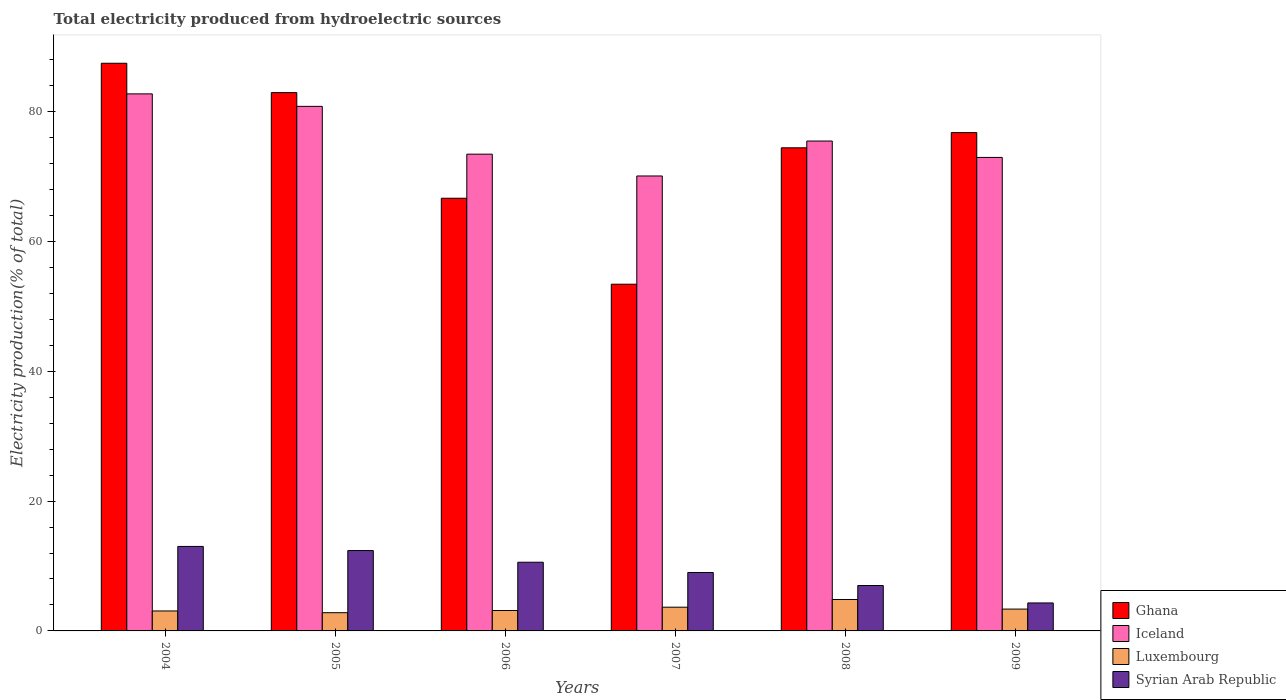Are the number of bars per tick equal to the number of legend labels?
Your response must be concise. Yes. How many bars are there on the 6th tick from the right?
Keep it short and to the point. 4. What is the label of the 4th group of bars from the left?
Provide a succinct answer. 2007. What is the total electricity produced in Luxembourg in 2006?
Your response must be concise. 3.15. Across all years, what is the maximum total electricity produced in Luxembourg?
Provide a succinct answer. 4.84. Across all years, what is the minimum total electricity produced in Iceland?
Provide a short and direct response. 70.08. What is the total total electricity produced in Iceland in the graph?
Your answer should be compact. 455.48. What is the difference between the total electricity produced in Iceland in 2004 and that in 2006?
Provide a short and direct response. 9.29. What is the difference between the total electricity produced in Luxembourg in 2008 and the total electricity produced in Iceland in 2006?
Ensure brevity in your answer.  -68.6. What is the average total electricity produced in Syrian Arab Republic per year?
Your answer should be compact. 9.38. In the year 2008, what is the difference between the total electricity produced in Syrian Arab Republic and total electricity produced in Iceland?
Ensure brevity in your answer.  -68.47. In how many years, is the total electricity produced in Iceland greater than 56 %?
Offer a terse response. 6. What is the ratio of the total electricity produced in Luxembourg in 2004 to that in 2005?
Your answer should be compact. 1.1. Is the total electricity produced in Luxembourg in 2006 less than that in 2009?
Offer a very short reply. Yes. Is the difference between the total electricity produced in Syrian Arab Republic in 2005 and 2006 greater than the difference between the total electricity produced in Iceland in 2005 and 2006?
Offer a very short reply. No. What is the difference between the highest and the second highest total electricity produced in Ghana?
Provide a short and direct response. 4.52. What is the difference between the highest and the lowest total electricity produced in Iceland?
Your response must be concise. 12.65. Is the sum of the total electricity produced in Syrian Arab Republic in 2005 and 2008 greater than the maximum total electricity produced in Luxembourg across all years?
Give a very brief answer. Yes. Is it the case that in every year, the sum of the total electricity produced in Iceland and total electricity produced in Ghana is greater than the sum of total electricity produced in Luxembourg and total electricity produced in Syrian Arab Republic?
Your answer should be very brief. No. What does the 4th bar from the left in 2009 represents?
Offer a terse response. Syrian Arab Republic. What does the 3rd bar from the right in 2005 represents?
Make the answer very short. Iceland. How many bars are there?
Provide a succinct answer. 24. Are all the bars in the graph horizontal?
Offer a terse response. No. Are the values on the major ticks of Y-axis written in scientific E-notation?
Your answer should be very brief. No. Does the graph contain grids?
Provide a succinct answer. No. How many legend labels are there?
Your response must be concise. 4. What is the title of the graph?
Offer a very short reply. Total electricity produced from hydroelectric sources. What is the Electricity production(% of total) of Ghana in 2004?
Make the answer very short. 87.45. What is the Electricity production(% of total) of Iceland in 2004?
Offer a very short reply. 82.73. What is the Electricity production(% of total) of Luxembourg in 2004?
Ensure brevity in your answer.  3.08. What is the Electricity production(% of total) in Syrian Arab Republic in 2004?
Keep it short and to the point. 13.02. What is the Electricity production(% of total) in Ghana in 2005?
Make the answer very short. 82.93. What is the Electricity production(% of total) of Iceland in 2005?
Keep it short and to the point. 80.81. What is the Electricity production(% of total) of Luxembourg in 2005?
Provide a succinct answer. 2.81. What is the Electricity production(% of total) in Syrian Arab Republic in 2005?
Your answer should be very brief. 12.38. What is the Electricity production(% of total) of Ghana in 2006?
Keep it short and to the point. 66.65. What is the Electricity production(% of total) in Iceland in 2006?
Your answer should be compact. 73.44. What is the Electricity production(% of total) in Luxembourg in 2006?
Your answer should be compact. 3.15. What is the Electricity production(% of total) of Syrian Arab Republic in 2006?
Make the answer very short. 10.58. What is the Electricity production(% of total) in Ghana in 2007?
Provide a short and direct response. 53.41. What is the Electricity production(% of total) in Iceland in 2007?
Your response must be concise. 70.08. What is the Electricity production(% of total) of Luxembourg in 2007?
Your answer should be very brief. 3.66. What is the Electricity production(% of total) in Syrian Arab Republic in 2007?
Provide a succinct answer. 9. What is the Electricity production(% of total) of Ghana in 2008?
Your answer should be compact. 74.42. What is the Electricity production(% of total) in Iceland in 2008?
Give a very brief answer. 75.47. What is the Electricity production(% of total) of Luxembourg in 2008?
Offer a terse response. 4.84. What is the Electricity production(% of total) of Syrian Arab Republic in 2008?
Provide a succinct answer. 6.99. What is the Electricity production(% of total) in Ghana in 2009?
Your answer should be very brief. 76.77. What is the Electricity production(% of total) in Iceland in 2009?
Ensure brevity in your answer.  72.94. What is the Electricity production(% of total) of Luxembourg in 2009?
Your answer should be compact. 3.36. What is the Electricity production(% of total) in Syrian Arab Republic in 2009?
Your answer should be very brief. 4.31. Across all years, what is the maximum Electricity production(% of total) of Ghana?
Provide a succinct answer. 87.45. Across all years, what is the maximum Electricity production(% of total) of Iceland?
Your response must be concise. 82.73. Across all years, what is the maximum Electricity production(% of total) of Luxembourg?
Offer a terse response. 4.84. Across all years, what is the maximum Electricity production(% of total) of Syrian Arab Republic?
Ensure brevity in your answer.  13.02. Across all years, what is the minimum Electricity production(% of total) in Ghana?
Provide a short and direct response. 53.41. Across all years, what is the minimum Electricity production(% of total) in Iceland?
Make the answer very short. 70.08. Across all years, what is the minimum Electricity production(% of total) in Luxembourg?
Provide a short and direct response. 2.81. Across all years, what is the minimum Electricity production(% of total) of Syrian Arab Republic?
Ensure brevity in your answer.  4.31. What is the total Electricity production(% of total) in Ghana in the graph?
Give a very brief answer. 441.63. What is the total Electricity production(% of total) of Iceland in the graph?
Keep it short and to the point. 455.48. What is the total Electricity production(% of total) in Luxembourg in the graph?
Keep it short and to the point. 20.89. What is the total Electricity production(% of total) in Syrian Arab Republic in the graph?
Ensure brevity in your answer.  56.28. What is the difference between the Electricity production(% of total) in Ghana in 2004 and that in 2005?
Your response must be concise. 4.52. What is the difference between the Electricity production(% of total) in Iceland in 2004 and that in 2005?
Keep it short and to the point. 1.92. What is the difference between the Electricity production(% of total) of Luxembourg in 2004 and that in 2005?
Your answer should be very brief. 0.27. What is the difference between the Electricity production(% of total) of Syrian Arab Republic in 2004 and that in 2005?
Your response must be concise. 0.64. What is the difference between the Electricity production(% of total) of Ghana in 2004 and that in 2006?
Provide a short and direct response. 20.79. What is the difference between the Electricity production(% of total) of Iceland in 2004 and that in 2006?
Your answer should be compact. 9.29. What is the difference between the Electricity production(% of total) in Luxembourg in 2004 and that in 2006?
Your answer should be compact. -0.07. What is the difference between the Electricity production(% of total) of Syrian Arab Republic in 2004 and that in 2006?
Your response must be concise. 2.43. What is the difference between the Electricity production(% of total) in Ghana in 2004 and that in 2007?
Your answer should be very brief. 34.04. What is the difference between the Electricity production(% of total) in Iceland in 2004 and that in 2007?
Offer a terse response. 12.65. What is the difference between the Electricity production(% of total) of Luxembourg in 2004 and that in 2007?
Ensure brevity in your answer.  -0.58. What is the difference between the Electricity production(% of total) of Syrian Arab Republic in 2004 and that in 2007?
Your response must be concise. 4.01. What is the difference between the Electricity production(% of total) of Ghana in 2004 and that in 2008?
Your answer should be very brief. 13.02. What is the difference between the Electricity production(% of total) of Iceland in 2004 and that in 2008?
Your answer should be very brief. 7.27. What is the difference between the Electricity production(% of total) in Luxembourg in 2004 and that in 2008?
Offer a very short reply. -1.77. What is the difference between the Electricity production(% of total) in Syrian Arab Republic in 2004 and that in 2008?
Your answer should be compact. 6.02. What is the difference between the Electricity production(% of total) of Ghana in 2004 and that in 2009?
Provide a short and direct response. 10.68. What is the difference between the Electricity production(% of total) in Iceland in 2004 and that in 2009?
Make the answer very short. 9.79. What is the difference between the Electricity production(% of total) in Luxembourg in 2004 and that in 2009?
Ensure brevity in your answer.  -0.29. What is the difference between the Electricity production(% of total) in Syrian Arab Republic in 2004 and that in 2009?
Your answer should be very brief. 8.71. What is the difference between the Electricity production(% of total) in Ghana in 2005 and that in 2006?
Your answer should be very brief. 16.27. What is the difference between the Electricity production(% of total) of Iceland in 2005 and that in 2006?
Offer a terse response. 7.36. What is the difference between the Electricity production(% of total) of Luxembourg in 2005 and that in 2006?
Keep it short and to the point. -0.34. What is the difference between the Electricity production(% of total) of Syrian Arab Republic in 2005 and that in 2006?
Ensure brevity in your answer.  1.8. What is the difference between the Electricity production(% of total) in Ghana in 2005 and that in 2007?
Make the answer very short. 29.52. What is the difference between the Electricity production(% of total) in Iceland in 2005 and that in 2007?
Make the answer very short. 10.72. What is the difference between the Electricity production(% of total) in Luxembourg in 2005 and that in 2007?
Provide a succinct answer. -0.85. What is the difference between the Electricity production(% of total) in Syrian Arab Republic in 2005 and that in 2007?
Make the answer very short. 3.38. What is the difference between the Electricity production(% of total) of Ghana in 2005 and that in 2008?
Provide a succinct answer. 8.5. What is the difference between the Electricity production(% of total) in Iceland in 2005 and that in 2008?
Provide a succinct answer. 5.34. What is the difference between the Electricity production(% of total) of Luxembourg in 2005 and that in 2008?
Your response must be concise. -2.03. What is the difference between the Electricity production(% of total) of Syrian Arab Republic in 2005 and that in 2008?
Provide a short and direct response. 5.39. What is the difference between the Electricity production(% of total) of Ghana in 2005 and that in 2009?
Make the answer very short. 6.16. What is the difference between the Electricity production(% of total) in Iceland in 2005 and that in 2009?
Give a very brief answer. 7.87. What is the difference between the Electricity production(% of total) in Luxembourg in 2005 and that in 2009?
Offer a very short reply. -0.56. What is the difference between the Electricity production(% of total) in Syrian Arab Republic in 2005 and that in 2009?
Your answer should be very brief. 8.07. What is the difference between the Electricity production(% of total) in Ghana in 2006 and that in 2007?
Give a very brief answer. 13.24. What is the difference between the Electricity production(% of total) of Iceland in 2006 and that in 2007?
Your response must be concise. 3.36. What is the difference between the Electricity production(% of total) in Luxembourg in 2006 and that in 2007?
Your answer should be very brief. -0.51. What is the difference between the Electricity production(% of total) of Syrian Arab Republic in 2006 and that in 2007?
Make the answer very short. 1.58. What is the difference between the Electricity production(% of total) in Ghana in 2006 and that in 2008?
Offer a very short reply. -7.77. What is the difference between the Electricity production(% of total) in Iceland in 2006 and that in 2008?
Ensure brevity in your answer.  -2.02. What is the difference between the Electricity production(% of total) of Luxembourg in 2006 and that in 2008?
Your answer should be compact. -1.7. What is the difference between the Electricity production(% of total) of Syrian Arab Republic in 2006 and that in 2008?
Provide a succinct answer. 3.59. What is the difference between the Electricity production(% of total) of Ghana in 2006 and that in 2009?
Provide a short and direct response. -10.11. What is the difference between the Electricity production(% of total) in Iceland in 2006 and that in 2009?
Make the answer very short. 0.5. What is the difference between the Electricity production(% of total) of Luxembourg in 2006 and that in 2009?
Provide a succinct answer. -0.22. What is the difference between the Electricity production(% of total) in Syrian Arab Republic in 2006 and that in 2009?
Your response must be concise. 6.27. What is the difference between the Electricity production(% of total) in Ghana in 2007 and that in 2008?
Give a very brief answer. -21.01. What is the difference between the Electricity production(% of total) of Iceland in 2007 and that in 2008?
Your response must be concise. -5.38. What is the difference between the Electricity production(% of total) in Luxembourg in 2007 and that in 2008?
Your response must be concise. -1.19. What is the difference between the Electricity production(% of total) of Syrian Arab Republic in 2007 and that in 2008?
Make the answer very short. 2.01. What is the difference between the Electricity production(% of total) of Ghana in 2007 and that in 2009?
Offer a very short reply. -23.36. What is the difference between the Electricity production(% of total) of Iceland in 2007 and that in 2009?
Provide a succinct answer. -2.86. What is the difference between the Electricity production(% of total) in Luxembourg in 2007 and that in 2009?
Keep it short and to the point. 0.29. What is the difference between the Electricity production(% of total) in Syrian Arab Republic in 2007 and that in 2009?
Your answer should be very brief. 4.69. What is the difference between the Electricity production(% of total) in Ghana in 2008 and that in 2009?
Offer a very short reply. -2.35. What is the difference between the Electricity production(% of total) of Iceland in 2008 and that in 2009?
Your response must be concise. 2.52. What is the difference between the Electricity production(% of total) of Luxembourg in 2008 and that in 2009?
Keep it short and to the point. 1.48. What is the difference between the Electricity production(% of total) in Syrian Arab Republic in 2008 and that in 2009?
Your answer should be compact. 2.69. What is the difference between the Electricity production(% of total) in Ghana in 2004 and the Electricity production(% of total) in Iceland in 2005?
Provide a short and direct response. 6.64. What is the difference between the Electricity production(% of total) in Ghana in 2004 and the Electricity production(% of total) in Luxembourg in 2005?
Keep it short and to the point. 84.64. What is the difference between the Electricity production(% of total) in Ghana in 2004 and the Electricity production(% of total) in Syrian Arab Republic in 2005?
Make the answer very short. 75.07. What is the difference between the Electricity production(% of total) of Iceland in 2004 and the Electricity production(% of total) of Luxembourg in 2005?
Make the answer very short. 79.92. What is the difference between the Electricity production(% of total) in Iceland in 2004 and the Electricity production(% of total) in Syrian Arab Republic in 2005?
Your answer should be very brief. 70.35. What is the difference between the Electricity production(% of total) of Luxembourg in 2004 and the Electricity production(% of total) of Syrian Arab Republic in 2005?
Ensure brevity in your answer.  -9.3. What is the difference between the Electricity production(% of total) in Ghana in 2004 and the Electricity production(% of total) in Iceland in 2006?
Your response must be concise. 14. What is the difference between the Electricity production(% of total) of Ghana in 2004 and the Electricity production(% of total) of Luxembourg in 2006?
Ensure brevity in your answer.  84.3. What is the difference between the Electricity production(% of total) of Ghana in 2004 and the Electricity production(% of total) of Syrian Arab Republic in 2006?
Your answer should be very brief. 76.87. What is the difference between the Electricity production(% of total) of Iceland in 2004 and the Electricity production(% of total) of Luxembourg in 2006?
Make the answer very short. 79.59. What is the difference between the Electricity production(% of total) in Iceland in 2004 and the Electricity production(% of total) in Syrian Arab Republic in 2006?
Ensure brevity in your answer.  72.15. What is the difference between the Electricity production(% of total) in Luxembourg in 2004 and the Electricity production(% of total) in Syrian Arab Republic in 2006?
Make the answer very short. -7.51. What is the difference between the Electricity production(% of total) in Ghana in 2004 and the Electricity production(% of total) in Iceland in 2007?
Your response must be concise. 17.36. What is the difference between the Electricity production(% of total) in Ghana in 2004 and the Electricity production(% of total) in Luxembourg in 2007?
Ensure brevity in your answer.  83.79. What is the difference between the Electricity production(% of total) in Ghana in 2004 and the Electricity production(% of total) in Syrian Arab Republic in 2007?
Give a very brief answer. 78.45. What is the difference between the Electricity production(% of total) of Iceland in 2004 and the Electricity production(% of total) of Luxembourg in 2007?
Ensure brevity in your answer.  79.08. What is the difference between the Electricity production(% of total) in Iceland in 2004 and the Electricity production(% of total) in Syrian Arab Republic in 2007?
Your answer should be compact. 73.73. What is the difference between the Electricity production(% of total) of Luxembourg in 2004 and the Electricity production(% of total) of Syrian Arab Republic in 2007?
Your response must be concise. -5.93. What is the difference between the Electricity production(% of total) of Ghana in 2004 and the Electricity production(% of total) of Iceland in 2008?
Ensure brevity in your answer.  11.98. What is the difference between the Electricity production(% of total) of Ghana in 2004 and the Electricity production(% of total) of Luxembourg in 2008?
Keep it short and to the point. 82.61. What is the difference between the Electricity production(% of total) of Ghana in 2004 and the Electricity production(% of total) of Syrian Arab Republic in 2008?
Give a very brief answer. 80.45. What is the difference between the Electricity production(% of total) in Iceland in 2004 and the Electricity production(% of total) in Luxembourg in 2008?
Offer a very short reply. 77.89. What is the difference between the Electricity production(% of total) of Iceland in 2004 and the Electricity production(% of total) of Syrian Arab Republic in 2008?
Offer a terse response. 75.74. What is the difference between the Electricity production(% of total) of Luxembourg in 2004 and the Electricity production(% of total) of Syrian Arab Republic in 2008?
Your answer should be very brief. -3.92. What is the difference between the Electricity production(% of total) of Ghana in 2004 and the Electricity production(% of total) of Iceland in 2009?
Your answer should be very brief. 14.51. What is the difference between the Electricity production(% of total) of Ghana in 2004 and the Electricity production(% of total) of Luxembourg in 2009?
Keep it short and to the point. 84.09. What is the difference between the Electricity production(% of total) in Ghana in 2004 and the Electricity production(% of total) in Syrian Arab Republic in 2009?
Provide a succinct answer. 83.14. What is the difference between the Electricity production(% of total) in Iceland in 2004 and the Electricity production(% of total) in Luxembourg in 2009?
Provide a short and direct response. 79.37. What is the difference between the Electricity production(% of total) in Iceland in 2004 and the Electricity production(% of total) in Syrian Arab Republic in 2009?
Offer a very short reply. 78.42. What is the difference between the Electricity production(% of total) in Luxembourg in 2004 and the Electricity production(% of total) in Syrian Arab Republic in 2009?
Your answer should be compact. -1.23. What is the difference between the Electricity production(% of total) of Ghana in 2005 and the Electricity production(% of total) of Iceland in 2006?
Provide a succinct answer. 9.48. What is the difference between the Electricity production(% of total) of Ghana in 2005 and the Electricity production(% of total) of Luxembourg in 2006?
Give a very brief answer. 79.78. What is the difference between the Electricity production(% of total) of Ghana in 2005 and the Electricity production(% of total) of Syrian Arab Republic in 2006?
Ensure brevity in your answer.  72.34. What is the difference between the Electricity production(% of total) in Iceland in 2005 and the Electricity production(% of total) in Luxembourg in 2006?
Keep it short and to the point. 77.66. What is the difference between the Electricity production(% of total) of Iceland in 2005 and the Electricity production(% of total) of Syrian Arab Republic in 2006?
Give a very brief answer. 70.23. What is the difference between the Electricity production(% of total) in Luxembourg in 2005 and the Electricity production(% of total) in Syrian Arab Republic in 2006?
Provide a succinct answer. -7.77. What is the difference between the Electricity production(% of total) in Ghana in 2005 and the Electricity production(% of total) in Iceland in 2007?
Make the answer very short. 12.84. What is the difference between the Electricity production(% of total) in Ghana in 2005 and the Electricity production(% of total) in Luxembourg in 2007?
Provide a succinct answer. 79.27. What is the difference between the Electricity production(% of total) in Ghana in 2005 and the Electricity production(% of total) in Syrian Arab Republic in 2007?
Offer a terse response. 73.93. What is the difference between the Electricity production(% of total) in Iceland in 2005 and the Electricity production(% of total) in Luxembourg in 2007?
Your response must be concise. 77.15. What is the difference between the Electricity production(% of total) in Iceland in 2005 and the Electricity production(% of total) in Syrian Arab Republic in 2007?
Your answer should be very brief. 71.81. What is the difference between the Electricity production(% of total) in Luxembourg in 2005 and the Electricity production(% of total) in Syrian Arab Republic in 2007?
Ensure brevity in your answer.  -6.19. What is the difference between the Electricity production(% of total) in Ghana in 2005 and the Electricity production(% of total) in Iceland in 2008?
Your answer should be compact. 7.46. What is the difference between the Electricity production(% of total) in Ghana in 2005 and the Electricity production(% of total) in Luxembourg in 2008?
Offer a terse response. 78.08. What is the difference between the Electricity production(% of total) of Ghana in 2005 and the Electricity production(% of total) of Syrian Arab Republic in 2008?
Offer a terse response. 75.93. What is the difference between the Electricity production(% of total) of Iceland in 2005 and the Electricity production(% of total) of Luxembourg in 2008?
Ensure brevity in your answer.  75.97. What is the difference between the Electricity production(% of total) in Iceland in 2005 and the Electricity production(% of total) in Syrian Arab Republic in 2008?
Your answer should be compact. 73.81. What is the difference between the Electricity production(% of total) of Luxembourg in 2005 and the Electricity production(% of total) of Syrian Arab Republic in 2008?
Make the answer very short. -4.19. What is the difference between the Electricity production(% of total) of Ghana in 2005 and the Electricity production(% of total) of Iceland in 2009?
Keep it short and to the point. 9.98. What is the difference between the Electricity production(% of total) in Ghana in 2005 and the Electricity production(% of total) in Luxembourg in 2009?
Offer a terse response. 79.56. What is the difference between the Electricity production(% of total) of Ghana in 2005 and the Electricity production(% of total) of Syrian Arab Republic in 2009?
Your response must be concise. 78.62. What is the difference between the Electricity production(% of total) in Iceland in 2005 and the Electricity production(% of total) in Luxembourg in 2009?
Keep it short and to the point. 77.45. What is the difference between the Electricity production(% of total) of Iceland in 2005 and the Electricity production(% of total) of Syrian Arab Republic in 2009?
Your answer should be compact. 76.5. What is the difference between the Electricity production(% of total) of Luxembourg in 2005 and the Electricity production(% of total) of Syrian Arab Republic in 2009?
Give a very brief answer. -1.5. What is the difference between the Electricity production(% of total) in Ghana in 2006 and the Electricity production(% of total) in Iceland in 2007?
Provide a succinct answer. -3.43. What is the difference between the Electricity production(% of total) in Ghana in 2006 and the Electricity production(% of total) in Luxembourg in 2007?
Ensure brevity in your answer.  63. What is the difference between the Electricity production(% of total) in Ghana in 2006 and the Electricity production(% of total) in Syrian Arab Republic in 2007?
Give a very brief answer. 57.65. What is the difference between the Electricity production(% of total) in Iceland in 2006 and the Electricity production(% of total) in Luxembourg in 2007?
Keep it short and to the point. 69.79. What is the difference between the Electricity production(% of total) of Iceland in 2006 and the Electricity production(% of total) of Syrian Arab Republic in 2007?
Your answer should be very brief. 64.44. What is the difference between the Electricity production(% of total) in Luxembourg in 2006 and the Electricity production(% of total) in Syrian Arab Republic in 2007?
Offer a terse response. -5.86. What is the difference between the Electricity production(% of total) of Ghana in 2006 and the Electricity production(% of total) of Iceland in 2008?
Provide a succinct answer. -8.81. What is the difference between the Electricity production(% of total) in Ghana in 2006 and the Electricity production(% of total) in Luxembourg in 2008?
Provide a short and direct response. 61.81. What is the difference between the Electricity production(% of total) of Ghana in 2006 and the Electricity production(% of total) of Syrian Arab Republic in 2008?
Provide a succinct answer. 59.66. What is the difference between the Electricity production(% of total) in Iceland in 2006 and the Electricity production(% of total) in Luxembourg in 2008?
Give a very brief answer. 68.6. What is the difference between the Electricity production(% of total) in Iceland in 2006 and the Electricity production(% of total) in Syrian Arab Republic in 2008?
Your response must be concise. 66.45. What is the difference between the Electricity production(% of total) of Luxembourg in 2006 and the Electricity production(% of total) of Syrian Arab Republic in 2008?
Ensure brevity in your answer.  -3.85. What is the difference between the Electricity production(% of total) of Ghana in 2006 and the Electricity production(% of total) of Iceland in 2009?
Ensure brevity in your answer.  -6.29. What is the difference between the Electricity production(% of total) in Ghana in 2006 and the Electricity production(% of total) in Luxembourg in 2009?
Provide a short and direct response. 63.29. What is the difference between the Electricity production(% of total) of Ghana in 2006 and the Electricity production(% of total) of Syrian Arab Republic in 2009?
Provide a succinct answer. 62.35. What is the difference between the Electricity production(% of total) of Iceland in 2006 and the Electricity production(% of total) of Luxembourg in 2009?
Offer a terse response. 70.08. What is the difference between the Electricity production(% of total) in Iceland in 2006 and the Electricity production(% of total) in Syrian Arab Republic in 2009?
Your response must be concise. 69.14. What is the difference between the Electricity production(% of total) in Luxembourg in 2006 and the Electricity production(% of total) in Syrian Arab Republic in 2009?
Your response must be concise. -1.16. What is the difference between the Electricity production(% of total) of Ghana in 2007 and the Electricity production(% of total) of Iceland in 2008?
Provide a short and direct response. -22.06. What is the difference between the Electricity production(% of total) in Ghana in 2007 and the Electricity production(% of total) in Luxembourg in 2008?
Give a very brief answer. 48.57. What is the difference between the Electricity production(% of total) of Ghana in 2007 and the Electricity production(% of total) of Syrian Arab Republic in 2008?
Provide a short and direct response. 46.42. What is the difference between the Electricity production(% of total) of Iceland in 2007 and the Electricity production(% of total) of Luxembourg in 2008?
Keep it short and to the point. 65.24. What is the difference between the Electricity production(% of total) in Iceland in 2007 and the Electricity production(% of total) in Syrian Arab Republic in 2008?
Offer a very short reply. 63.09. What is the difference between the Electricity production(% of total) in Luxembourg in 2007 and the Electricity production(% of total) in Syrian Arab Republic in 2008?
Offer a terse response. -3.34. What is the difference between the Electricity production(% of total) in Ghana in 2007 and the Electricity production(% of total) in Iceland in 2009?
Your answer should be compact. -19.53. What is the difference between the Electricity production(% of total) of Ghana in 2007 and the Electricity production(% of total) of Luxembourg in 2009?
Give a very brief answer. 50.05. What is the difference between the Electricity production(% of total) of Ghana in 2007 and the Electricity production(% of total) of Syrian Arab Republic in 2009?
Keep it short and to the point. 49.1. What is the difference between the Electricity production(% of total) in Iceland in 2007 and the Electricity production(% of total) in Luxembourg in 2009?
Provide a short and direct response. 66.72. What is the difference between the Electricity production(% of total) in Iceland in 2007 and the Electricity production(% of total) in Syrian Arab Republic in 2009?
Keep it short and to the point. 65.78. What is the difference between the Electricity production(% of total) in Luxembourg in 2007 and the Electricity production(% of total) in Syrian Arab Republic in 2009?
Provide a short and direct response. -0.65. What is the difference between the Electricity production(% of total) in Ghana in 2008 and the Electricity production(% of total) in Iceland in 2009?
Provide a succinct answer. 1.48. What is the difference between the Electricity production(% of total) of Ghana in 2008 and the Electricity production(% of total) of Luxembourg in 2009?
Provide a succinct answer. 71.06. What is the difference between the Electricity production(% of total) of Ghana in 2008 and the Electricity production(% of total) of Syrian Arab Republic in 2009?
Make the answer very short. 70.11. What is the difference between the Electricity production(% of total) in Iceland in 2008 and the Electricity production(% of total) in Luxembourg in 2009?
Keep it short and to the point. 72.1. What is the difference between the Electricity production(% of total) in Iceland in 2008 and the Electricity production(% of total) in Syrian Arab Republic in 2009?
Ensure brevity in your answer.  71.16. What is the difference between the Electricity production(% of total) in Luxembourg in 2008 and the Electricity production(% of total) in Syrian Arab Republic in 2009?
Offer a very short reply. 0.53. What is the average Electricity production(% of total) in Ghana per year?
Make the answer very short. 73.61. What is the average Electricity production(% of total) in Iceland per year?
Keep it short and to the point. 75.91. What is the average Electricity production(% of total) in Luxembourg per year?
Your answer should be very brief. 3.48. What is the average Electricity production(% of total) in Syrian Arab Republic per year?
Provide a succinct answer. 9.38. In the year 2004, what is the difference between the Electricity production(% of total) in Ghana and Electricity production(% of total) in Iceland?
Provide a short and direct response. 4.72. In the year 2004, what is the difference between the Electricity production(% of total) of Ghana and Electricity production(% of total) of Luxembourg?
Provide a short and direct response. 84.37. In the year 2004, what is the difference between the Electricity production(% of total) in Ghana and Electricity production(% of total) in Syrian Arab Republic?
Keep it short and to the point. 74.43. In the year 2004, what is the difference between the Electricity production(% of total) of Iceland and Electricity production(% of total) of Luxembourg?
Your response must be concise. 79.66. In the year 2004, what is the difference between the Electricity production(% of total) of Iceland and Electricity production(% of total) of Syrian Arab Republic?
Make the answer very short. 69.72. In the year 2004, what is the difference between the Electricity production(% of total) of Luxembourg and Electricity production(% of total) of Syrian Arab Republic?
Provide a succinct answer. -9.94. In the year 2005, what is the difference between the Electricity production(% of total) in Ghana and Electricity production(% of total) in Iceland?
Ensure brevity in your answer.  2.12. In the year 2005, what is the difference between the Electricity production(% of total) of Ghana and Electricity production(% of total) of Luxembourg?
Your answer should be very brief. 80.12. In the year 2005, what is the difference between the Electricity production(% of total) in Ghana and Electricity production(% of total) in Syrian Arab Republic?
Give a very brief answer. 70.55. In the year 2005, what is the difference between the Electricity production(% of total) in Iceland and Electricity production(% of total) in Luxembourg?
Provide a succinct answer. 78. In the year 2005, what is the difference between the Electricity production(% of total) of Iceland and Electricity production(% of total) of Syrian Arab Republic?
Your response must be concise. 68.43. In the year 2005, what is the difference between the Electricity production(% of total) of Luxembourg and Electricity production(% of total) of Syrian Arab Republic?
Keep it short and to the point. -9.57. In the year 2006, what is the difference between the Electricity production(% of total) in Ghana and Electricity production(% of total) in Iceland?
Ensure brevity in your answer.  -6.79. In the year 2006, what is the difference between the Electricity production(% of total) in Ghana and Electricity production(% of total) in Luxembourg?
Provide a succinct answer. 63.51. In the year 2006, what is the difference between the Electricity production(% of total) of Ghana and Electricity production(% of total) of Syrian Arab Republic?
Keep it short and to the point. 56.07. In the year 2006, what is the difference between the Electricity production(% of total) of Iceland and Electricity production(% of total) of Luxembourg?
Keep it short and to the point. 70.3. In the year 2006, what is the difference between the Electricity production(% of total) of Iceland and Electricity production(% of total) of Syrian Arab Republic?
Provide a short and direct response. 62.86. In the year 2006, what is the difference between the Electricity production(% of total) in Luxembourg and Electricity production(% of total) in Syrian Arab Republic?
Ensure brevity in your answer.  -7.44. In the year 2007, what is the difference between the Electricity production(% of total) in Ghana and Electricity production(% of total) in Iceland?
Make the answer very short. -16.67. In the year 2007, what is the difference between the Electricity production(% of total) of Ghana and Electricity production(% of total) of Luxembourg?
Ensure brevity in your answer.  49.76. In the year 2007, what is the difference between the Electricity production(% of total) of Ghana and Electricity production(% of total) of Syrian Arab Republic?
Ensure brevity in your answer.  44.41. In the year 2007, what is the difference between the Electricity production(% of total) of Iceland and Electricity production(% of total) of Luxembourg?
Make the answer very short. 66.43. In the year 2007, what is the difference between the Electricity production(% of total) in Iceland and Electricity production(% of total) in Syrian Arab Republic?
Make the answer very short. 61.08. In the year 2007, what is the difference between the Electricity production(% of total) in Luxembourg and Electricity production(% of total) in Syrian Arab Republic?
Your answer should be very brief. -5.35. In the year 2008, what is the difference between the Electricity production(% of total) of Ghana and Electricity production(% of total) of Iceland?
Provide a short and direct response. -1.04. In the year 2008, what is the difference between the Electricity production(% of total) in Ghana and Electricity production(% of total) in Luxembourg?
Your answer should be very brief. 69.58. In the year 2008, what is the difference between the Electricity production(% of total) of Ghana and Electricity production(% of total) of Syrian Arab Republic?
Provide a short and direct response. 67.43. In the year 2008, what is the difference between the Electricity production(% of total) in Iceland and Electricity production(% of total) in Luxembourg?
Keep it short and to the point. 70.62. In the year 2008, what is the difference between the Electricity production(% of total) of Iceland and Electricity production(% of total) of Syrian Arab Republic?
Give a very brief answer. 68.47. In the year 2008, what is the difference between the Electricity production(% of total) of Luxembourg and Electricity production(% of total) of Syrian Arab Republic?
Your answer should be compact. -2.15. In the year 2009, what is the difference between the Electricity production(% of total) in Ghana and Electricity production(% of total) in Iceland?
Keep it short and to the point. 3.83. In the year 2009, what is the difference between the Electricity production(% of total) of Ghana and Electricity production(% of total) of Luxembourg?
Provide a succinct answer. 73.41. In the year 2009, what is the difference between the Electricity production(% of total) of Ghana and Electricity production(% of total) of Syrian Arab Republic?
Keep it short and to the point. 72.46. In the year 2009, what is the difference between the Electricity production(% of total) in Iceland and Electricity production(% of total) in Luxembourg?
Give a very brief answer. 69.58. In the year 2009, what is the difference between the Electricity production(% of total) of Iceland and Electricity production(% of total) of Syrian Arab Republic?
Keep it short and to the point. 68.63. In the year 2009, what is the difference between the Electricity production(% of total) in Luxembourg and Electricity production(% of total) in Syrian Arab Republic?
Ensure brevity in your answer.  -0.95. What is the ratio of the Electricity production(% of total) in Ghana in 2004 to that in 2005?
Your response must be concise. 1.05. What is the ratio of the Electricity production(% of total) in Iceland in 2004 to that in 2005?
Give a very brief answer. 1.02. What is the ratio of the Electricity production(% of total) of Luxembourg in 2004 to that in 2005?
Make the answer very short. 1.1. What is the ratio of the Electricity production(% of total) in Syrian Arab Republic in 2004 to that in 2005?
Offer a terse response. 1.05. What is the ratio of the Electricity production(% of total) of Ghana in 2004 to that in 2006?
Keep it short and to the point. 1.31. What is the ratio of the Electricity production(% of total) of Iceland in 2004 to that in 2006?
Ensure brevity in your answer.  1.13. What is the ratio of the Electricity production(% of total) in Luxembourg in 2004 to that in 2006?
Your response must be concise. 0.98. What is the ratio of the Electricity production(% of total) of Syrian Arab Republic in 2004 to that in 2006?
Keep it short and to the point. 1.23. What is the ratio of the Electricity production(% of total) of Ghana in 2004 to that in 2007?
Keep it short and to the point. 1.64. What is the ratio of the Electricity production(% of total) in Iceland in 2004 to that in 2007?
Provide a short and direct response. 1.18. What is the ratio of the Electricity production(% of total) of Luxembourg in 2004 to that in 2007?
Give a very brief answer. 0.84. What is the ratio of the Electricity production(% of total) in Syrian Arab Republic in 2004 to that in 2007?
Your answer should be compact. 1.45. What is the ratio of the Electricity production(% of total) of Ghana in 2004 to that in 2008?
Your answer should be very brief. 1.18. What is the ratio of the Electricity production(% of total) of Iceland in 2004 to that in 2008?
Your answer should be compact. 1.1. What is the ratio of the Electricity production(% of total) in Luxembourg in 2004 to that in 2008?
Offer a very short reply. 0.64. What is the ratio of the Electricity production(% of total) in Syrian Arab Republic in 2004 to that in 2008?
Keep it short and to the point. 1.86. What is the ratio of the Electricity production(% of total) of Ghana in 2004 to that in 2009?
Offer a very short reply. 1.14. What is the ratio of the Electricity production(% of total) of Iceland in 2004 to that in 2009?
Provide a short and direct response. 1.13. What is the ratio of the Electricity production(% of total) of Luxembourg in 2004 to that in 2009?
Offer a terse response. 0.91. What is the ratio of the Electricity production(% of total) in Syrian Arab Republic in 2004 to that in 2009?
Your response must be concise. 3.02. What is the ratio of the Electricity production(% of total) of Ghana in 2005 to that in 2006?
Keep it short and to the point. 1.24. What is the ratio of the Electricity production(% of total) of Iceland in 2005 to that in 2006?
Offer a terse response. 1.1. What is the ratio of the Electricity production(% of total) of Luxembourg in 2005 to that in 2006?
Offer a terse response. 0.89. What is the ratio of the Electricity production(% of total) of Syrian Arab Republic in 2005 to that in 2006?
Offer a very short reply. 1.17. What is the ratio of the Electricity production(% of total) of Ghana in 2005 to that in 2007?
Offer a terse response. 1.55. What is the ratio of the Electricity production(% of total) of Iceland in 2005 to that in 2007?
Give a very brief answer. 1.15. What is the ratio of the Electricity production(% of total) of Luxembourg in 2005 to that in 2007?
Give a very brief answer. 0.77. What is the ratio of the Electricity production(% of total) of Syrian Arab Republic in 2005 to that in 2007?
Make the answer very short. 1.38. What is the ratio of the Electricity production(% of total) of Ghana in 2005 to that in 2008?
Provide a short and direct response. 1.11. What is the ratio of the Electricity production(% of total) of Iceland in 2005 to that in 2008?
Your answer should be compact. 1.07. What is the ratio of the Electricity production(% of total) in Luxembourg in 2005 to that in 2008?
Give a very brief answer. 0.58. What is the ratio of the Electricity production(% of total) of Syrian Arab Republic in 2005 to that in 2008?
Give a very brief answer. 1.77. What is the ratio of the Electricity production(% of total) of Ghana in 2005 to that in 2009?
Keep it short and to the point. 1.08. What is the ratio of the Electricity production(% of total) in Iceland in 2005 to that in 2009?
Your answer should be compact. 1.11. What is the ratio of the Electricity production(% of total) in Luxembourg in 2005 to that in 2009?
Your answer should be very brief. 0.83. What is the ratio of the Electricity production(% of total) in Syrian Arab Republic in 2005 to that in 2009?
Keep it short and to the point. 2.87. What is the ratio of the Electricity production(% of total) in Ghana in 2006 to that in 2007?
Give a very brief answer. 1.25. What is the ratio of the Electricity production(% of total) of Iceland in 2006 to that in 2007?
Provide a short and direct response. 1.05. What is the ratio of the Electricity production(% of total) of Luxembourg in 2006 to that in 2007?
Provide a short and direct response. 0.86. What is the ratio of the Electricity production(% of total) in Syrian Arab Republic in 2006 to that in 2007?
Offer a very short reply. 1.18. What is the ratio of the Electricity production(% of total) in Ghana in 2006 to that in 2008?
Offer a terse response. 0.9. What is the ratio of the Electricity production(% of total) of Iceland in 2006 to that in 2008?
Make the answer very short. 0.97. What is the ratio of the Electricity production(% of total) of Luxembourg in 2006 to that in 2008?
Your response must be concise. 0.65. What is the ratio of the Electricity production(% of total) in Syrian Arab Republic in 2006 to that in 2008?
Your response must be concise. 1.51. What is the ratio of the Electricity production(% of total) in Ghana in 2006 to that in 2009?
Keep it short and to the point. 0.87. What is the ratio of the Electricity production(% of total) of Luxembourg in 2006 to that in 2009?
Offer a very short reply. 0.94. What is the ratio of the Electricity production(% of total) in Syrian Arab Republic in 2006 to that in 2009?
Your response must be concise. 2.46. What is the ratio of the Electricity production(% of total) of Ghana in 2007 to that in 2008?
Offer a very short reply. 0.72. What is the ratio of the Electricity production(% of total) of Iceland in 2007 to that in 2008?
Offer a terse response. 0.93. What is the ratio of the Electricity production(% of total) in Luxembourg in 2007 to that in 2008?
Make the answer very short. 0.75. What is the ratio of the Electricity production(% of total) in Syrian Arab Republic in 2007 to that in 2008?
Your answer should be compact. 1.29. What is the ratio of the Electricity production(% of total) of Ghana in 2007 to that in 2009?
Your answer should be very brief. 0.7. What is the ratio of the Electricity production(% of total) in Iceland in 2007 to that in 2009?
Make the answer very short. 0.96. What is the ratio of the Electricity production(% of total) in Luxembourg in 2007 to that in 2009?
Make the answer very short. 1.09. What is the ratio of the Electricity production(% of total) of Syrian Arab Republic in 2007 to that in 2009?
Your answer should be very brief. 2.09. What is the ratio of the Electricity production(% of total) of Ghana in 2008 to that in 2009?
Ensure brevity in your answer.  0.97. What is the ratio of the Electricity production(% of total) of Iceland in 2008 to that in 2009?
Ensure brevity in your answer.  1.03. What is the ratio of the Electricity production(% of total) in Luxembourg in 2008 to that in 2009?
Offer a very short reply. 1.44. What is the ratio of the Electricity production(% of total) in Syrian Arab Republic in 2008 to that in 2009?
Offer a terse response. 1.62. What is the difference between the highest and the second highest Electricity production(% of total) of Ghana?
Provide a short and direct response. 4.52. What is the difference between the highest and the second highest Electricity production(% of total) in Iceland?
Your answer should be very brief. 1.92. What is the difference between the highest and the second highest Electricity production(% of total) of Luxembourg?
Provide a succinct answer. 1.19. What is the difference between the highest and the second highest Electricity production(% of total) in Syrian Arab Republic?
Your answer should be very brief. 0.64. What is the difference between the highest and the lowest Electricity production(% of total) in Ghana?
Give a very brief answer. 34.04. What is the difference between the highest and the lowest Electricity production(% of total) of Iceland?
Provide a succinct answer. 12.65. What is the difference between the highest and the lowest Electricity production(% of total) in Luxembourg?
Provide a short and direct response. 2.03. What is the difference between the highest and the lowest Electricity production(% of total) of Syrian Arab Republic?
Give a very brief answer. 8.71. 